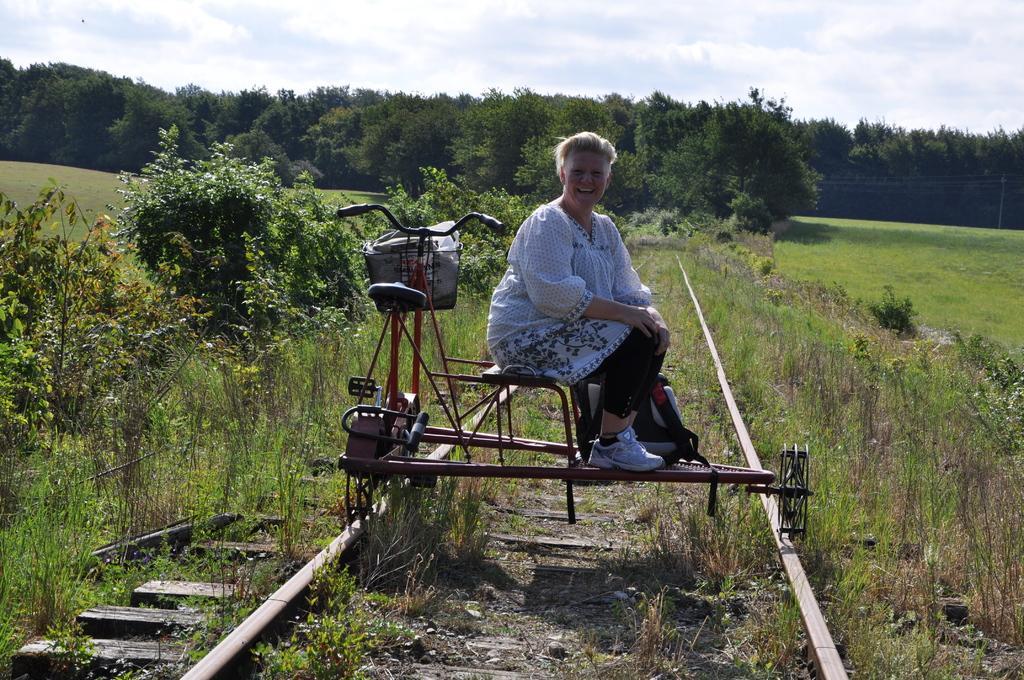Can you describe this image briefly? In this image, we can see a bicycle and there is a bag in the basket and there is a lady sitting on the stand and we can see an other bag. In the background, there are trees and plants. At the top, there are clouds in the sky and at the bottom, there is a track. 